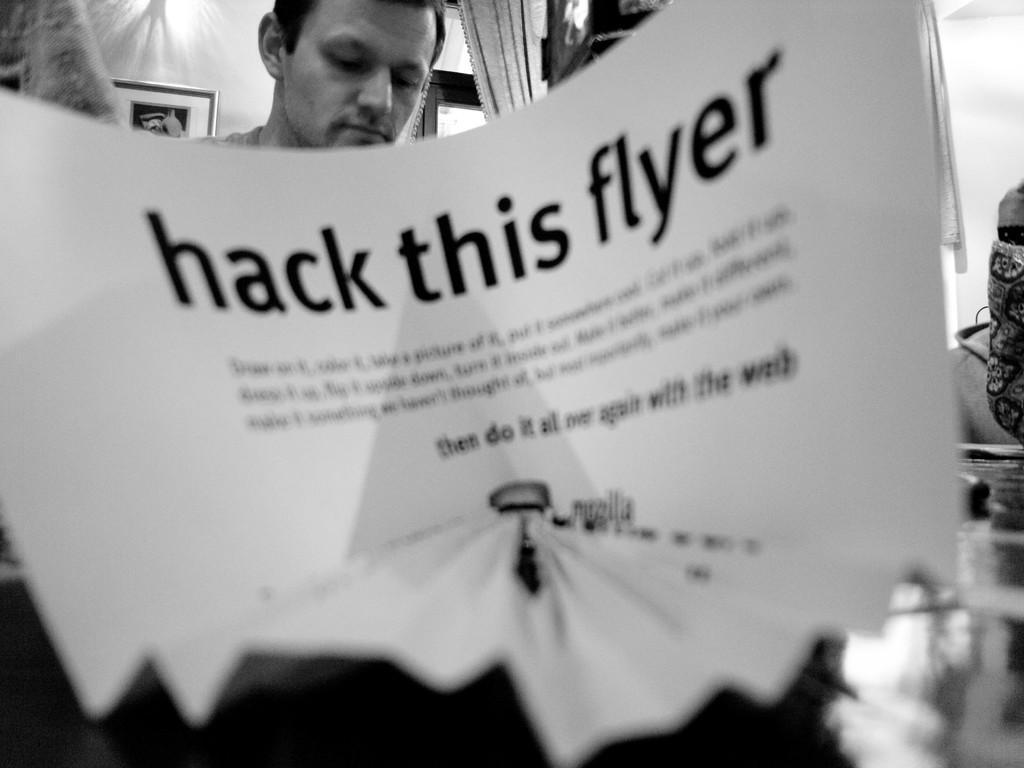Describe this image in one or two sentences. In this picture I can see a paper with the text on it, in the background there is a man, on the left side it looks like a photo frame. 